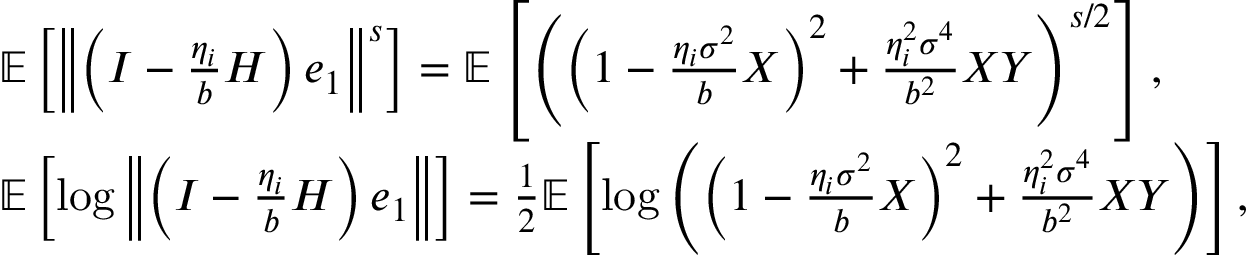Convert formula to latex. <formula><loc_0><loc_0><loc_500><loc_500>\begin{array} { r l } & { \mathbb { E } \left [ \left \| \left ( I - \frac { \eta _ { i } } { b } H \right ) e _ { 1 } \right \| ^ { s } \right ] = \mathbb { E } \left [ \left ( \left ( 1 - \frac { \eta _ { i } \sigma ^ { 2 } } { b } X \right ) ^ { 2 } + \frac { \eta _ { i } ^ { 2 } \sigma ^ { 4 } } { b ^ { 2 } } X Y \right ) ^ { s / 2 } \right ] , } \\ & { \mathbb { E } \left [ \log \left \| \left ( I - \frac { \eta _ { i } } { b } H \right ) e _ { 1 } \right \| \right ] = \frac { 1 } { 2 } \mathbb { E } \left [ \log \left ( \left ( 1 - \frac { \eta _ { i } \sigma ^ { 2 } } { b } X \right ) ^ { 2 } + \frac { \eta _ { i } ^ { 2 } \sigma ^ { 4 } } { b ^ { 2 } } X Y \right ) \right ] , } \end{array}</formula> 